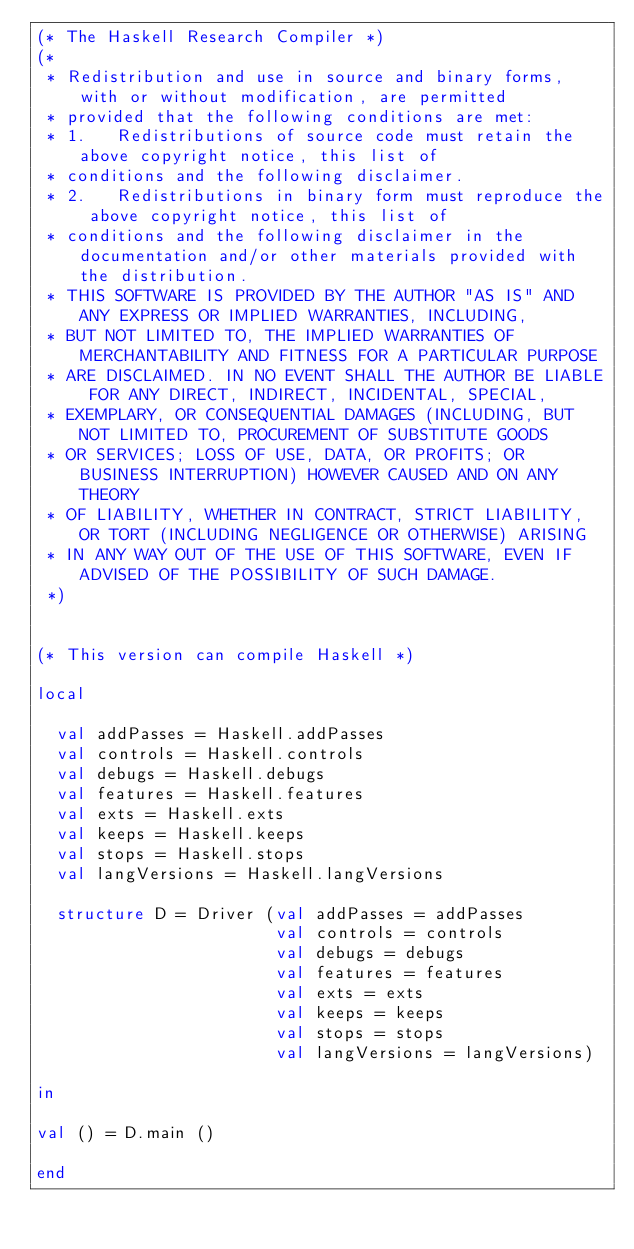Convert code to text. <code><loc_0><loc_0><loc_500><loc_500><_SML_>(* The Haskell Research Compiler *)
(*
 * Redistribution and use in source and binary forms, with or without modification, are permitted 
 * provided that the following conditions are met:
 * 1.   Redistributions of source code must retain the above copyright notice, this list of 
 * conditions and the following disclaimer.
 * 2.   Redistributions in binary form must reproduce the above copyright notice, this list of
 * conditions and the following disclaimer in the documentation and/or other materials provided with the distribution.
 * THIS SOFTWARE IS PROVIDED BY THE AUTHOR "AS IS" AND ANY EXPRESS OR IMPLIED WARRANTIES, INCLUDING,
 * BUT NOT LIMITED TO, THE IMPLIED WARRANTIES OF MERCHANTABILITY AND FITNESS FOR A PARTICULAR PURPOSE
 * ARE DISCLAIMED. IN NO EVENT SHALL THE AUTHOR BE LIABLE FOR ANY DIRECT, INDIRECT, INCIDENTAL, SPECIAL,
 * EXEMPLARY, OR CONSEQUENTIAL DAMAGES (INCLUDING, BUT NOT LIMITED TO, PROCUREMENT OF SUBSTITUTE GOODS
 * OR SERVICES; LOSS OF USE, DATA, OR PROFITS; OR BUSINESS INTERRUPTION) HOWEVER CAUSED AND ON ANY THEORY
 * OF LIABILITY, WHETHER IN CONTRACT, STRICT LIABILITY, OR TORT (INCLUDING NEGLIGENCE OR OTHERWISE) ARISING
 * IN ANY WAY OUT OF THE USE OF THIS SOFTWARE, EVEN IF ADVISED OF THE POSSIBILITY OF SUCH DAMAGE.
 *)


(* This version can compile Haskell *)

local

  val addPasses = Haskell.addPasses
  val controls = Haskell.controls
  val debugs = Haskell.debugs
  val features = Haskell.features
  val exts = Haskell.exts
  val keeps = Haskell.keeps
  val stops = Haskell.stops
  val langVersions = Haskell.langVersions

  structure D = Driver (val addPasses = addPasses
                        val controls = controls
                        val debugs = debugs
                        val features = features
                        val exts = exts
                        val keeps = keeps
                        val stops = stops
                        val langVersions = langVersions)

in

val () = D.main ()

end
</code> 